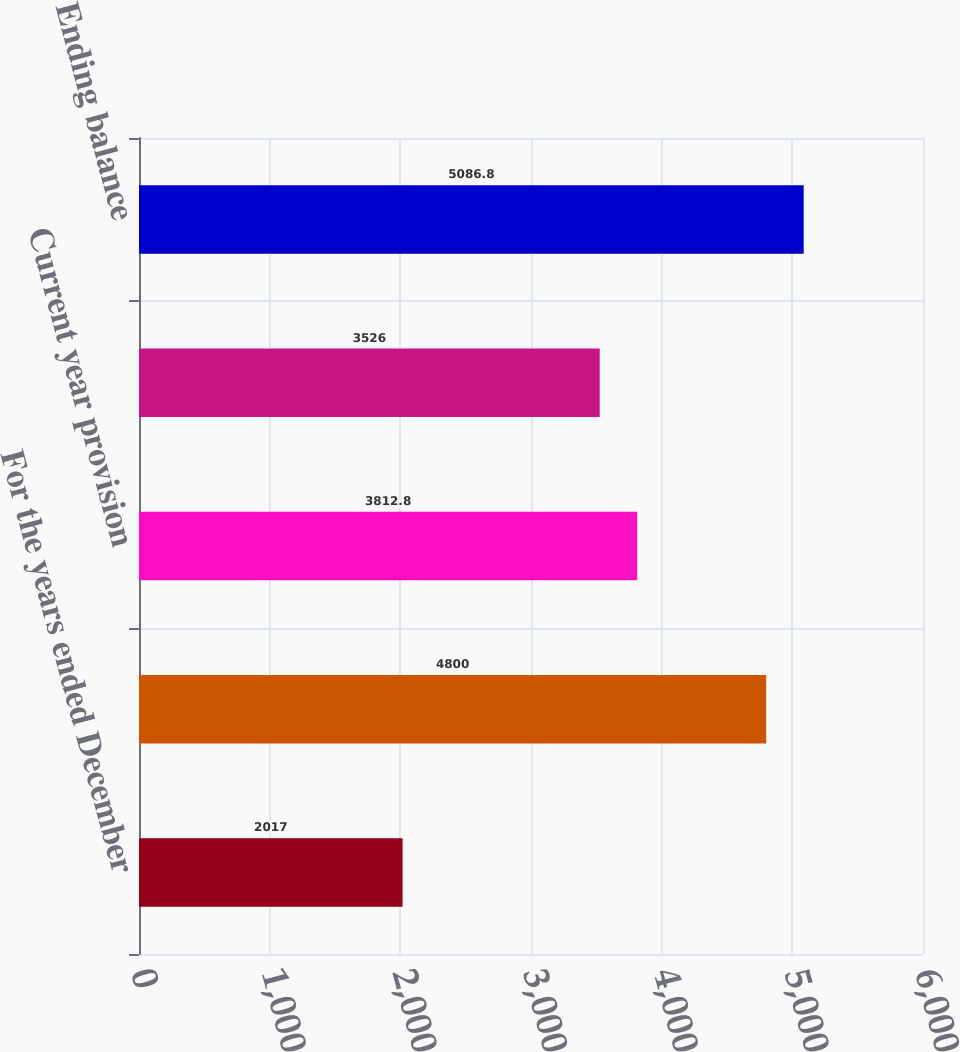Convert chart to OTSL. <chart><loc_0><loc_0><loc_500><loc_500><bar_chart><fcel>For the years ended December<fcel>Beginning balance<fcel>Current year provision<fcel>Settlements claims and<fcel>Ending balance<nl><fcel>2017<fcel>4800<fcel>3812.8<fcel>3526<fcel>5086.8<nl></chart> 